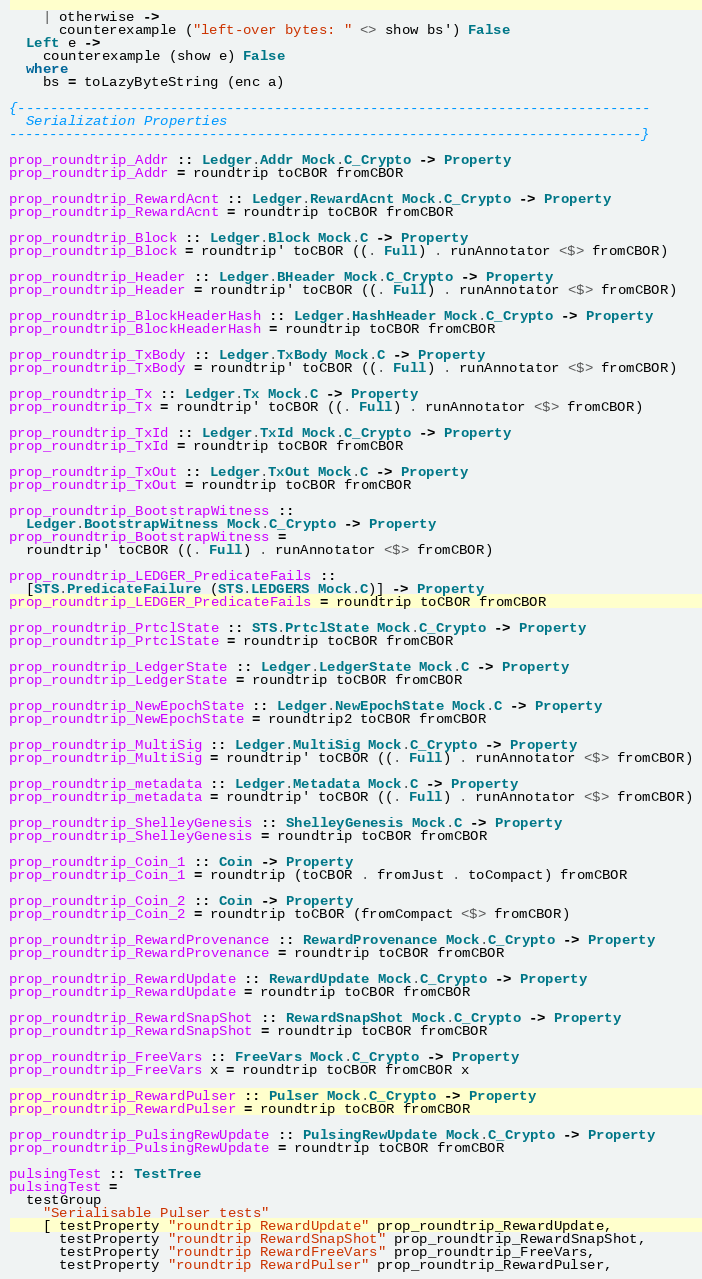Convert code to text. <code><loc_0><loc_0><loc_500><loc_500><_Haskell_>    | otherwise ->
      counterexample ("left-over bytes: " <> show bs') False
  Left e ->
    counterexample (show e) False
  where
    bs = toLazyByteString (enc a)

{-------------------------------------------------------------------------------
  Serialization Properties
-------------------------------------------------------------------------------}

prop_roundtrip_Addr :: Ledger.Addr Mock.C_Crypto -> Property
prop_roundtrip_Addr = roundtrip toCBOR fromCBOR

prop_roundtrip_RewardAcnt :: Ledger.RewardAcnt Mock.C_Crypto -> Property
prop_roundtrip_RewardAcnt = roundtrip toCBOR fromCBOR

prop_roundtrip_Block :: Ledger.Block Mock.C -> Property
prop_roundtrip_Block = roundtrip' toCBOR ((. Full) . runAnnotator <$> fromCBOR)

prop_roundtrip_Header :: Ledger.BHeader Mock.C_Crypto -> Property
prop_roundtrip_Header = roundtrip' toCBOR ((. Full) . runAnnotator <$> fromCBOR)

prop_roundtrip_BlockHeaderHash :: Ledger.HashHeader Mock.C_Crypto -> Property
prop_roundtrip_BlockHeaderHash = roundtrip toCBOR fromCBOR

prop_roundtrip_TxBody :: Ledger.TxBody Mock.C -> Property
prop_roundtrip_TxBody = roundtrip' toCBOR ((. Full) . runAnnotator <$> fromCBOR)

prop_roundtrip_Tx :: Ledger.Tx Mock.C -> Property
prop_roundtrip_Tx = roundtrip' toCBOR ((. Full) . runAnnotator <$> fromCBOR)

prop_roundtrip_TxId :: Ledger.TxId Mock.C_Crypto -> Property
prop_roundtrip_TxId = roundtrip toCBOR fromCBOR

prop_roundtrip_TxOut :: Ledger.TxOut Mock.C -> Property
prop_roundtrip_TxOut = roundtrip toCBOR fromCBOR

prop_roundtrip_BootstrapWitness ::
  Ledger.BootstrapWitness Mock.C_Crypto -> Property
prop_roundtrip_BootstrapWitness =
  roundtrip' toCBOR ((. Full) . runAnnotator <$> fromCBOR)

prop_roundtrip_LEDGER_PredicateFails ::
  [STS.PredicateFailure (STS.LEDGERS Mock.C)] -> Property
prop_roundtrip_LEDGER_PredicateFails = roundtrip toCBOR fromCBOR

prop_roundtrip_PrtclState :: STS.PrtclState Mock.C_Crypto -> Property
prop_roundtrip_PrtclState = roundtrip toCBOR fromCBOR

prop_roundtrip_LedgerState :: Ledger.LedgerState Mock.C -> Property
prop_roundtrip_LedgerState = roundtrip toCBOR fromCBOR

prop_roundtrip_NewEpochState :: Ledger.NewEpochState Mock.C -> Property
prop_roundtrip_NewEpochState = roundtrip2 toCBOR fromCBOR

prop_roundtrip_MultiSig :: Ledger.MultiSig Mock.C_Crypto -> Property
prop_roundtrip_MultiSig = roundtrip' toCBOR ((. Full) . runAnnotator <$> fromCBOR)

prop_roundtrip_metadata :: Ledger.Metadata Mock.C -> Property
prop_roundtrip_metadata = roundtrip' toCBOR ((. Full) . runAnnotator <$> fromCBOR)

prop_roundtrip_ShelleyGenesis :: ShelleyGenesis Mock.C -> Property
prop_roundtrip_ShelleyGenesis = roundtrip toCBOR fromCBOR

prop_roundtrip_Coin_1 :: Coin -> Property
prop_roundtrip_Coin_1 = roundtrip (toCBOR . fromJust . toCompact) fromCBOR

prop_roundtrip_Coin_2 :: Coin -> Property
prop_roundtrip_Coin_2 = roundtrip toCBOR (fromCompact <$> fromCBOR)

prop_roundtrip_RewardProvenance :: RewardProvenance Mock.C_Crypto -> Property
prop_roundtrip_RewardProvenance = roundtrip toCBOR fromCBOR

prop_roundtrip_RewardUpdate :: RewardUpdate Mock.C_Crypto -> Property
prop_roundtrip_RewardUpdate = roundtrip toCBOR fromCBOR

prop_roundtrip_RewardSnapShot :: RewardSnapShot Mock.C_Crypto -> Property
prop_roundtrip_RewardSnapShot = roundtrip toCBOR fromCBOR

prop_roundtrip_FreeVars :: FreeVars Mock.C_Crypto -> Property
prop_roundtrip_FreeVars x = roundtrip toCBOR fromCBOR x

prop_roundtrip_RewardPulser :: Pulser Mock.C_Crypto -> Property
prop_roundtrip_RewardPulser = roundtrip toCBOR fromCBOR

prop_roundtrip_PulsingRewUpdate :: PulsingRewUpdate Mock.C_Crypto -> Property
prop_roundtrip_PulsingRewUpdate = roundtrip toCBOR fromCBOR

pulsingTest :: TestTree
pulsingTest =
  testGroup
    "Serialisable Pulser tests"
    [ testProperty "roundtrip RewardUpdate" prop_roundtrip_RewardUpdate,
      testProperty "roundtrip RewardSnapShot" prop_roundtrip_RewardSnapShot,
      testProperty "roundtrip RewardFreeVars" prop_roundtrip_FreeVars,
      testProperty "roundtrip RewardPulser" prop_roundtrip_RewardPulser,</code> 